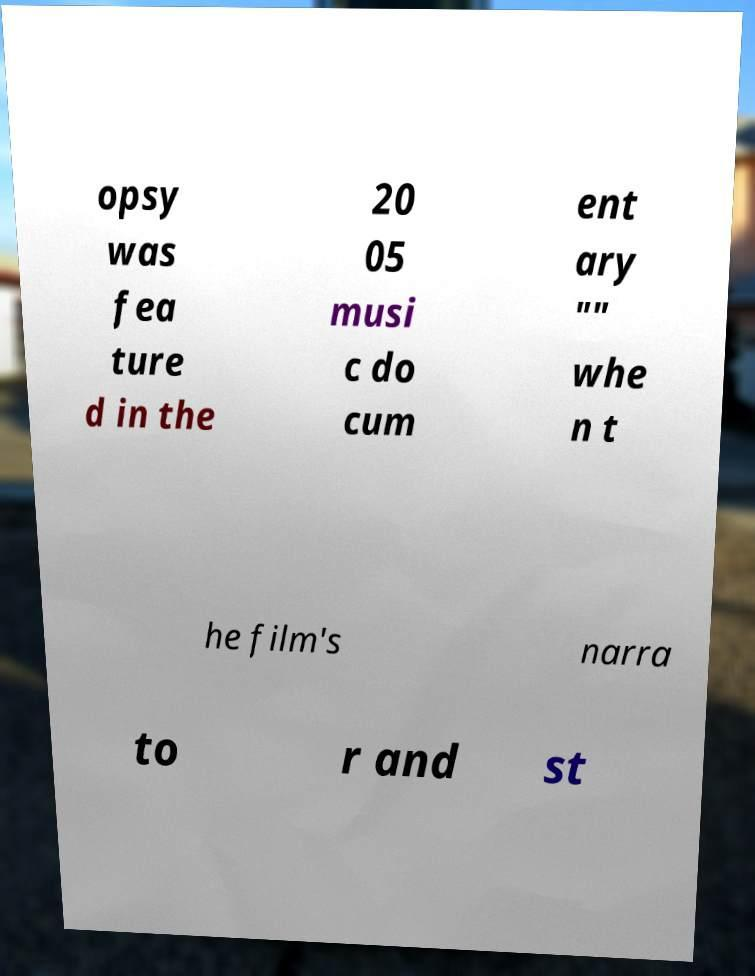I need the written content from this picture converted into text. Can you do that? opsy was fea ture d in the 20 05 musi c do cum ent ary "" whe n t he film's narra to r and st 